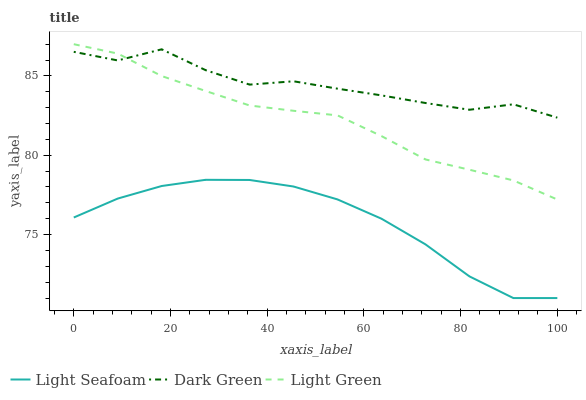Does Light Seafoam have the minimum area under the curve?
Answer yes or no. Yes. Does Dark Green have the maximum area under the curve?
Answer yes or no. Yes. Does Light Green have the minimum area under the curve?
Answer yes or no. No. Does Light Green have the maximum area under the curve?
Answer yes or no. No. Is Light Green the smoothest?
Answer yes or no. Yes. Is Dark Green the roughest?
Answer yes or no. Yes. Is Dark Green the smoothest?
Answer yes or no. No. Is Light Green the roughest?
Answer yes or no. No. Does Light Seafoam have the lowest value?
Answer yes or no. Yes. Does Light Green have the lowest value?
Answer yes or no. No. Does Light Green have the highest value?
Answer yes or no. Yes. Does Dark Green have the highest value?
Answer yes or no. No. Is Light Seafoam less than Light Green?
Answer yes or no. Yes. Is Light Green greater than Light Seafoam?
Answer yes or no. Yes. Does Dark Green intersect Light Green?
Answer yes or no. Yes. Is Dark Green less than Light Green?
Answer yes or no. No. Is Dark Green greater than Light Green?
Answer yes or no. No. Does Light Seafoam intersect Light Green?
Answer yes or no. No. 